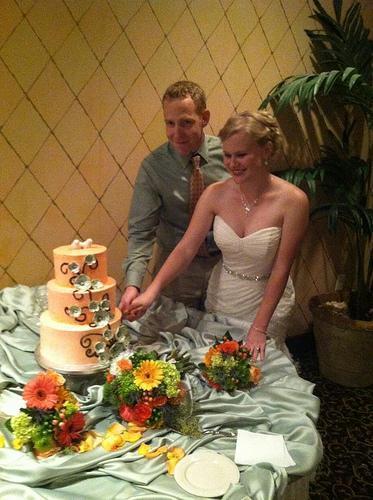How many people are pictured?
Give a very brief answer. 2. 